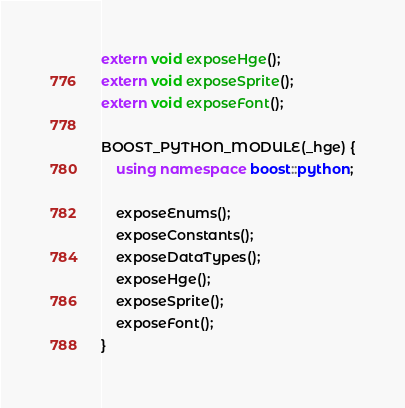<code> <loc_0><loc_0><loc_500><loc_500><_C++_>extern void exposeHge();
extern void exposeSprite();
extern void exposeFont();

BOOST_PYTHON_MODULE(_hge) {
    using namespace boost::python;

    exposeEnums();
    exposeConstants();
    exposeDataTypes();
    exposeHge();
    exposeSprite();
    exposeFont();
}
</code> 